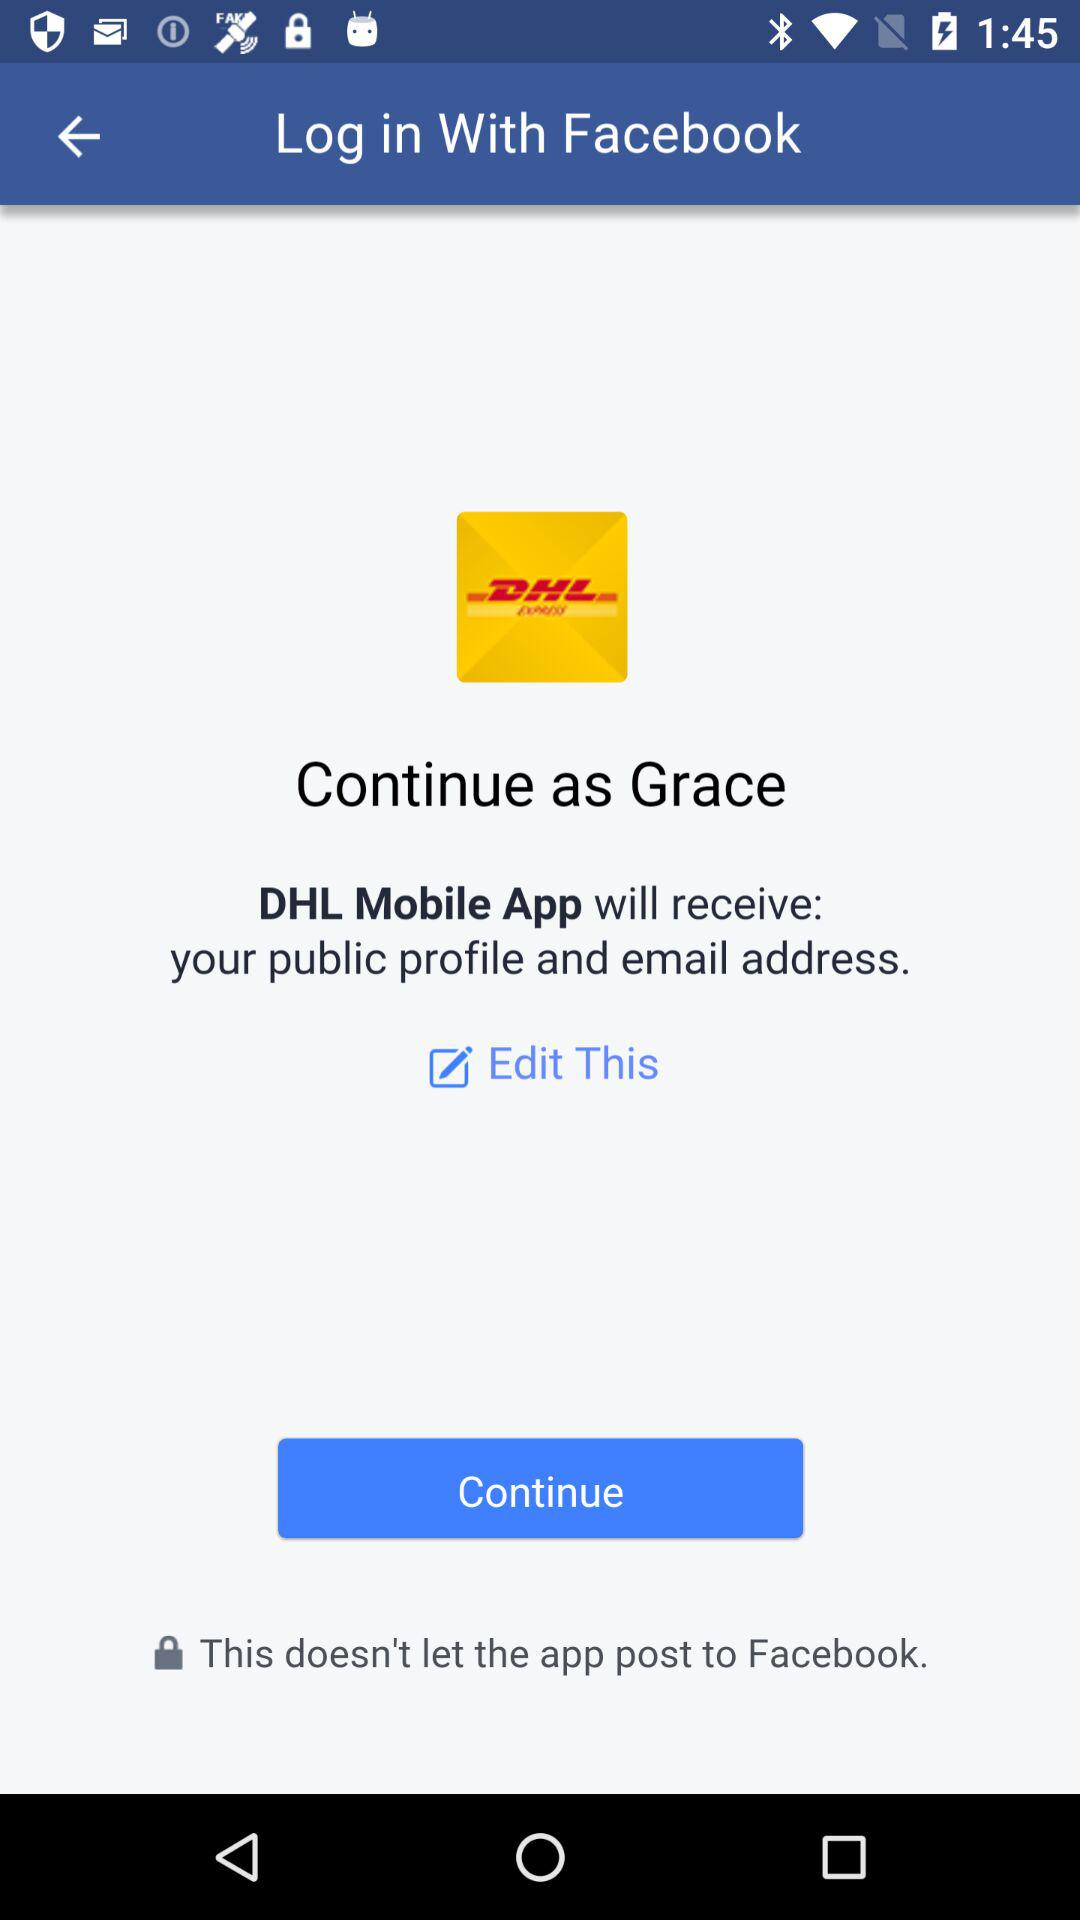What is the login name? The login name is Grace. 